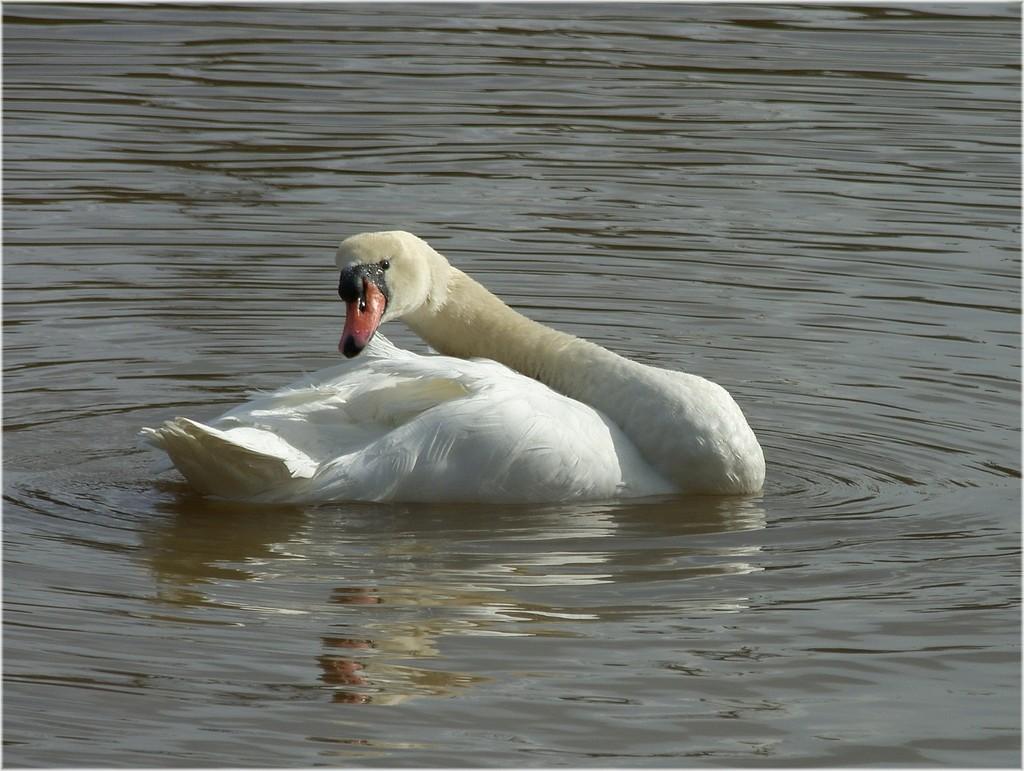Please provide a concise description of this image. In this image we can see a duck floating on the water and surrounded by the water. 